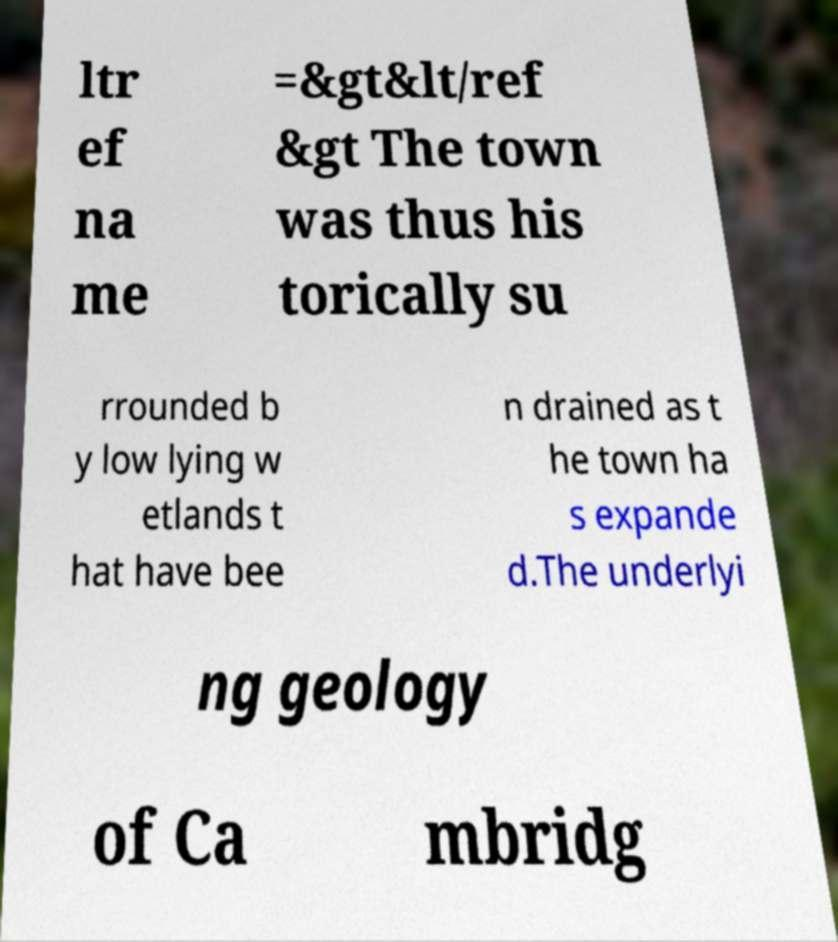What messages or text are displayed in this image? I need them in a readable, typed format. ltr ef na me =&gt&lt/ref &gt The town was thus his torically su rrounded b y low lying w etlands t hat have bee n drained as t he town ha s expande d.The underlyi ng geology of Ca mbridg 